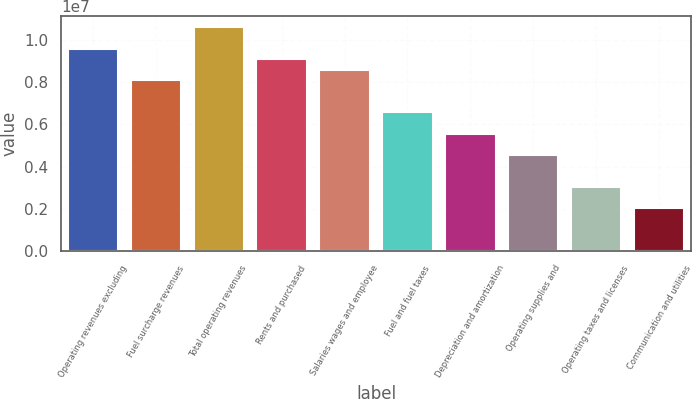Convert chart. <chart><loc_0><loc_0><loc_500><loc_500><bar_chart><fcel>Operating revenues excluding<fcel>Fuel surcharge revenues<fcel>Total operating revenues<fcel>Rents and purchased<fcel>Salaries wages and employee<fcel>Fuel and fuel taxes<fcel>Depreciation and amortization<fcel>Operating supplies and<fcel>Operating taxes and licenses<fcel>Communication and utilities<nl><fcel>9.60446e+06<fcel>8.08797e+06<fcel>1.06155e+07<fcel>9.09896e+06<fcel>8.59347e+06<fcel>6.57147e+06<fcel>5.56048e+06<fcel>4.54948e+06<fcel>3.03299e+06<fcel>2.02199e+06<nl></chart> 